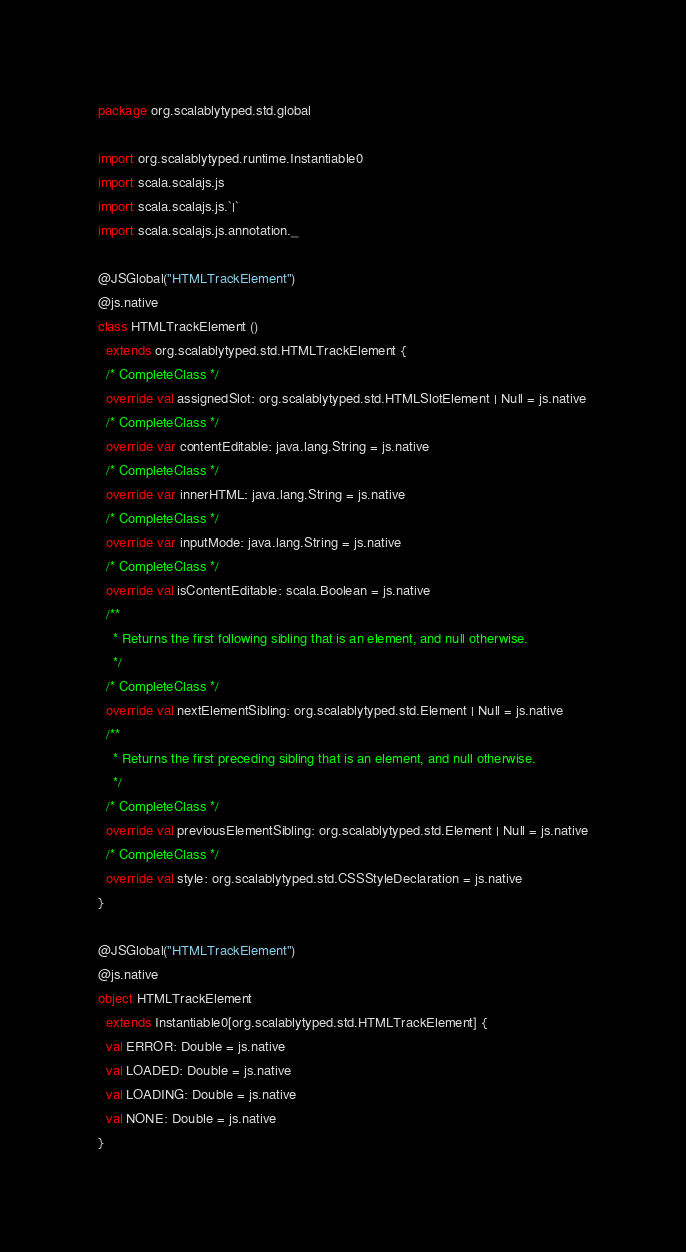Convert code to text. <code><loc_0><loc_0><loc_500><loc_500><_Scala_>package org.scalablytyped.std.global

import org.scalablytyped.runtime.Instantiable0
import scala.scalajs.js
import scala.scalajs.js.`|`
import scala.scalajs.js.annotation._

@JSGlobal("HTMLTrackElement")
@js.native
class HTMLTrackElement ()
  extends org.scalablytyped.std.HTMLTrackElement {
  /* CompleteClass */
  override val assignedSlot: org.scalablytyped.std.HTMLSlotElement | Null = js.native
  /* CompleteClass */
  override var contentEditable: java.lang.String = js.native
  /* CompleteClass */
  override var innerHTML: java.lang.String = js.native
  /* CompleteClass */
  override var inputMode: java.lang.String = js.native
  /* CompleteClass */
  override val isContentEditable: scala.Boolean = js.native
  /**
    * Returns the first following sibling that is an element, and null otherwise.
    */
  /* CompleteClass */
  override val nextElementSibling: org.scalablytyped.std.Element | Null = js.native
  /**
    * Returns the first preceding sibling that is an element, and null otherwise.
    */
  /* CompleteClass */
  override val previousElementSibling: org.scalablytyped.std.Element | Null = js.native
  /* CompleteClass */
  override val style: org.scalablytyped.std.CSSStyleDeclaration = js.native
}

@JSGlobal("HTMLTrackElement")
@js.native
object HTMLTrackElement
  extends Instantiable0[org.scalablytyped.std.HTMLTrackElement] {
  val ERROR: Double = js.native
  val LOADED: Double = js.native
  val LOADING: Double = js.native
  val NONE: Double = js.native
}

</code> 